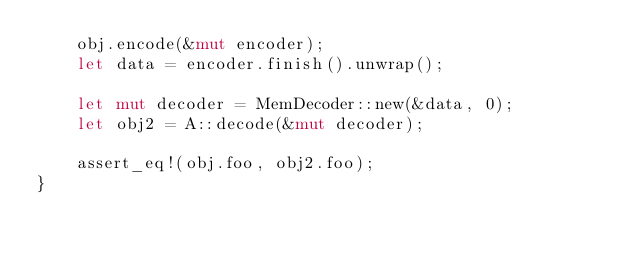Convert code to text. <code><loc_0><loc_0><loc_500><loc_500><_Rust_>    obj.encode(&mut encoder);
    let data = encoder.finish().unwrap();

    let mut decoder = MemDecoder::new(&data, 0);
    let obj2 = A::decode(&mut decoder);

    assert_eq!(obj.foo, obj2.foo);
}
</code> 